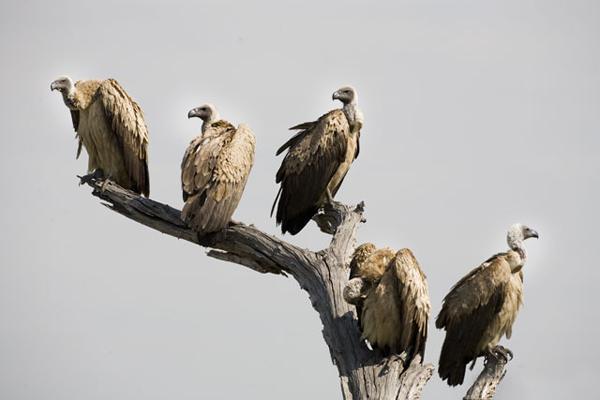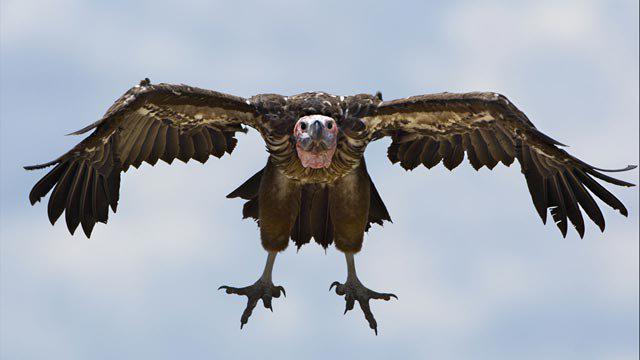The first image is the image on the left, the second image is the image on the right. Considering the images on both sides, is "At least one bird is flying in the air." valid? Answer yes or no. Yes. 